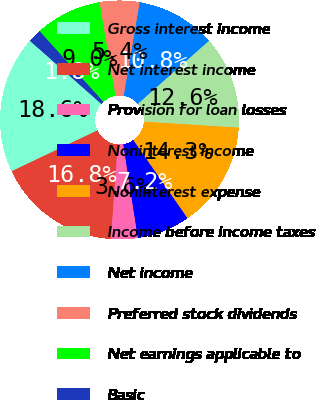Convert chart to OTSL. <chart><loc_0><loc_0><loc_500><loc_500><pie_chart><fcel>Gross interest income<fcel>Net interest income<fcel>Provision for loan losses<fcel>Noninterest income<fcel>Noninterest expense<fcel>Income before income taxes<fcel>Net income<fcel>Preferred stock dividends<fcel>Net earnings applicable to<fcel>Basic<nl><fcel>18.58%<fcel>16.79%<fcel>3.6%<fcel>7.18%<fcel>14.34%<fcel>12.55%<fcel>10.76%<fcel>5.39%<fcel>8.97%<fcel>1.81%<nl></chart> 